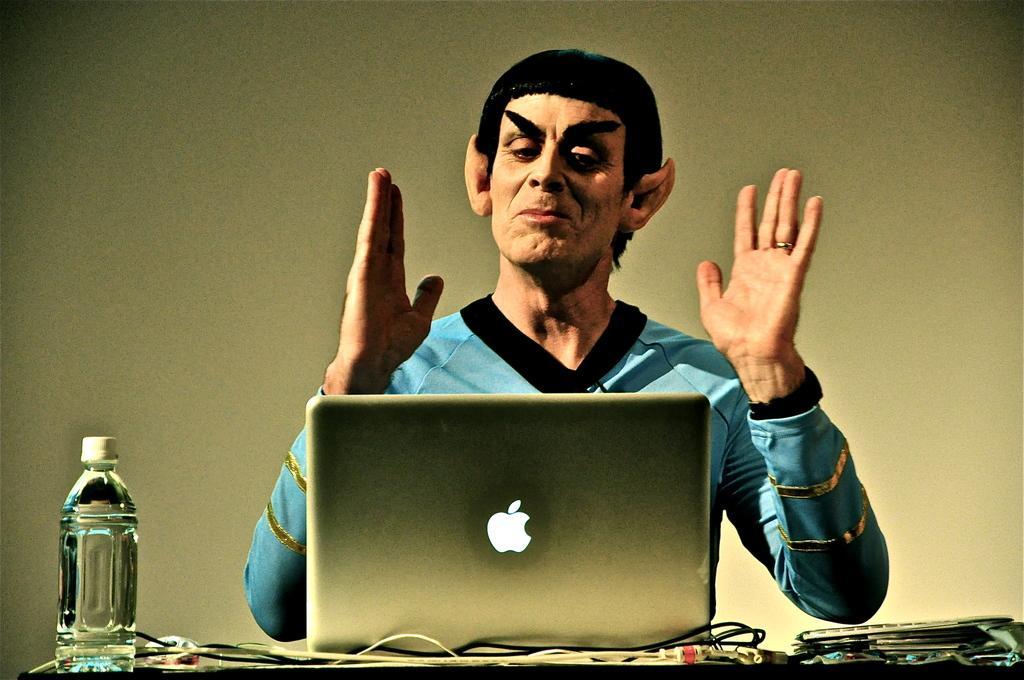Could you give a brief overview of what you see in this image? In the middle of the image a man is sitting and looking into the laptop. Bottom of the image there is a table, On the table there is a bottle and there are some papers and wires. Behind the person there is a wall. 